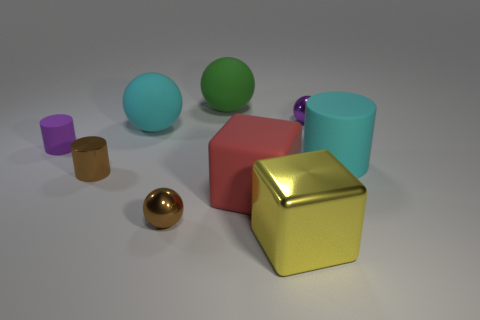There is a metallic thing that is both left of the red thing and on the right side of the brown cylinder; what is its shape?
Keep it short and to the point. Sphere. What is the size of the cyan thing that is the same shape as the tiny purple shiny thing?
Ensure brevity in your answer.  Large. Is the number of big blocks that are in front of the large yellow metal thing less than the number of big cylinders?
Offer a terse response. Yes. How big is the rubber cylinder left of the yellow thing?
Provide a succinct answer. Small. What color is the other shiny object that is the same shape as the large red object?
Provide a succinct answer. Yellow. What number of metallic spheres are the same color as the large matte block?
Provide a succinct answer. 0. Is there anything else that is the same shape as the red object?
Ensure brevity in your answer.  Yes. There is a matte ball behind the big cyan object on the left side of the big metal block; is there a yellow metal object that is to the left of it?
Keep it short and to the point. No. How many large cyan spheres are the same material as the brown cylinder?
Make the answer very short. 0. There is a rubber cylinder that is on the left side of the small brown shiny sphere; does it have the same size as the brown thing that is in front of the small metallic cylinder?
Provide a short and direct response. Yes. 